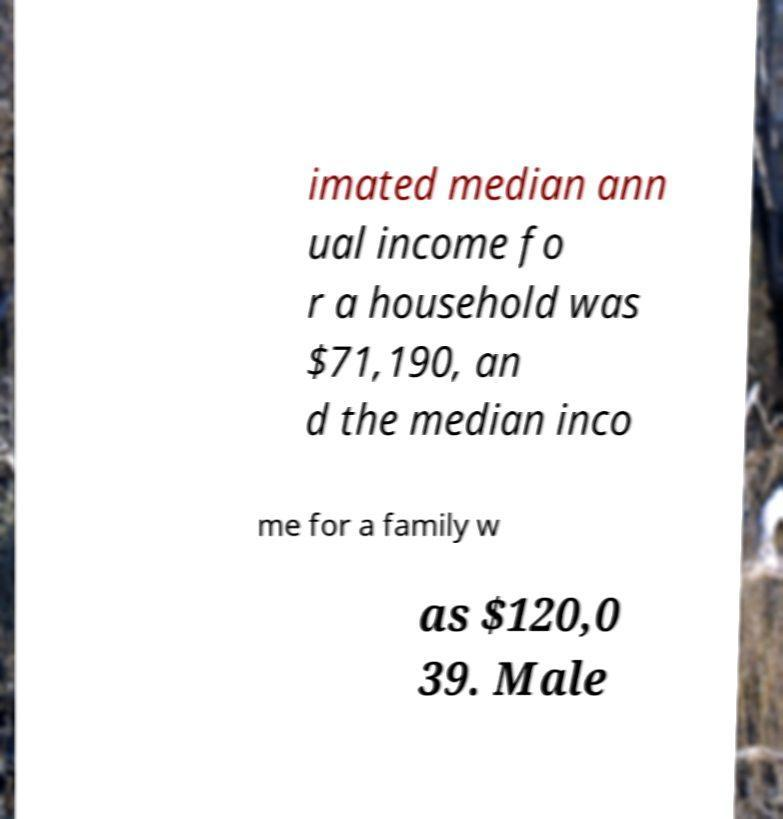Could you extract and type out the text from this image? imated median ann ual income fo r a household was $71,190, an d the median inco me for a family w as $120,0 39. Male 